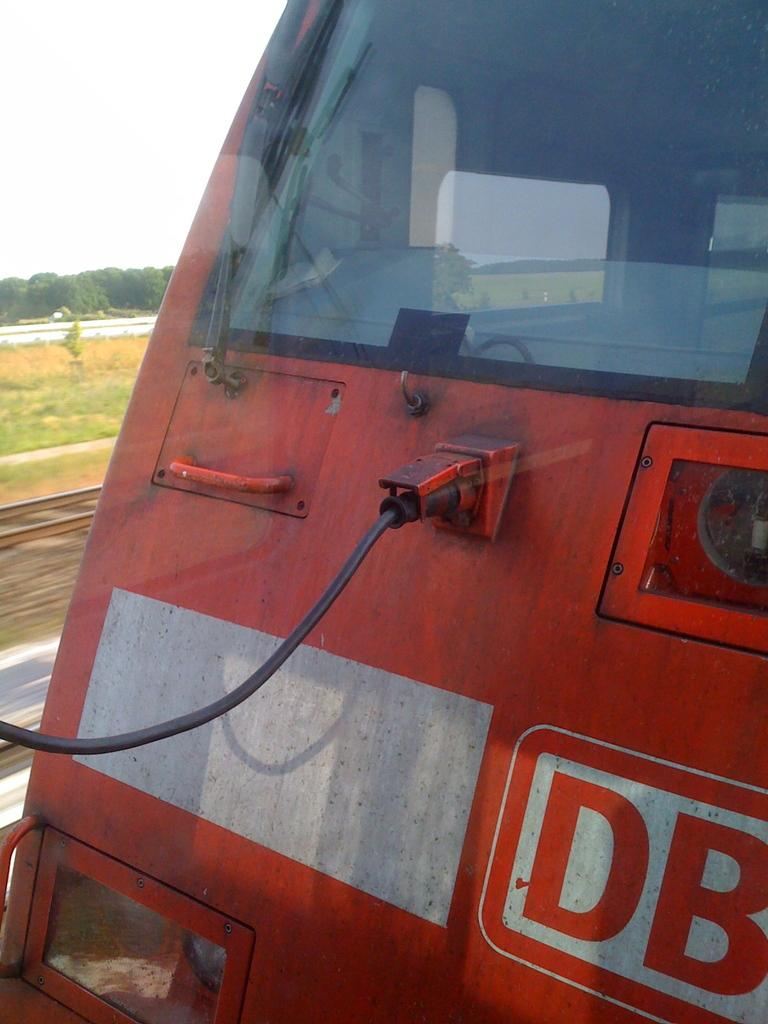What is the main subject of the image? The main subject of the image is the front part of a train. What can be seen on the ground beside the train? There is grass on the surface beside the train. What type of vegetation is present near the grass? There are trees beside the grass. What type of calculator can be seen on the train in the image? There is no calculator present on the train in the image. How many toothbrushes are visible in the image? There are no toothbrushes visible in the image. 